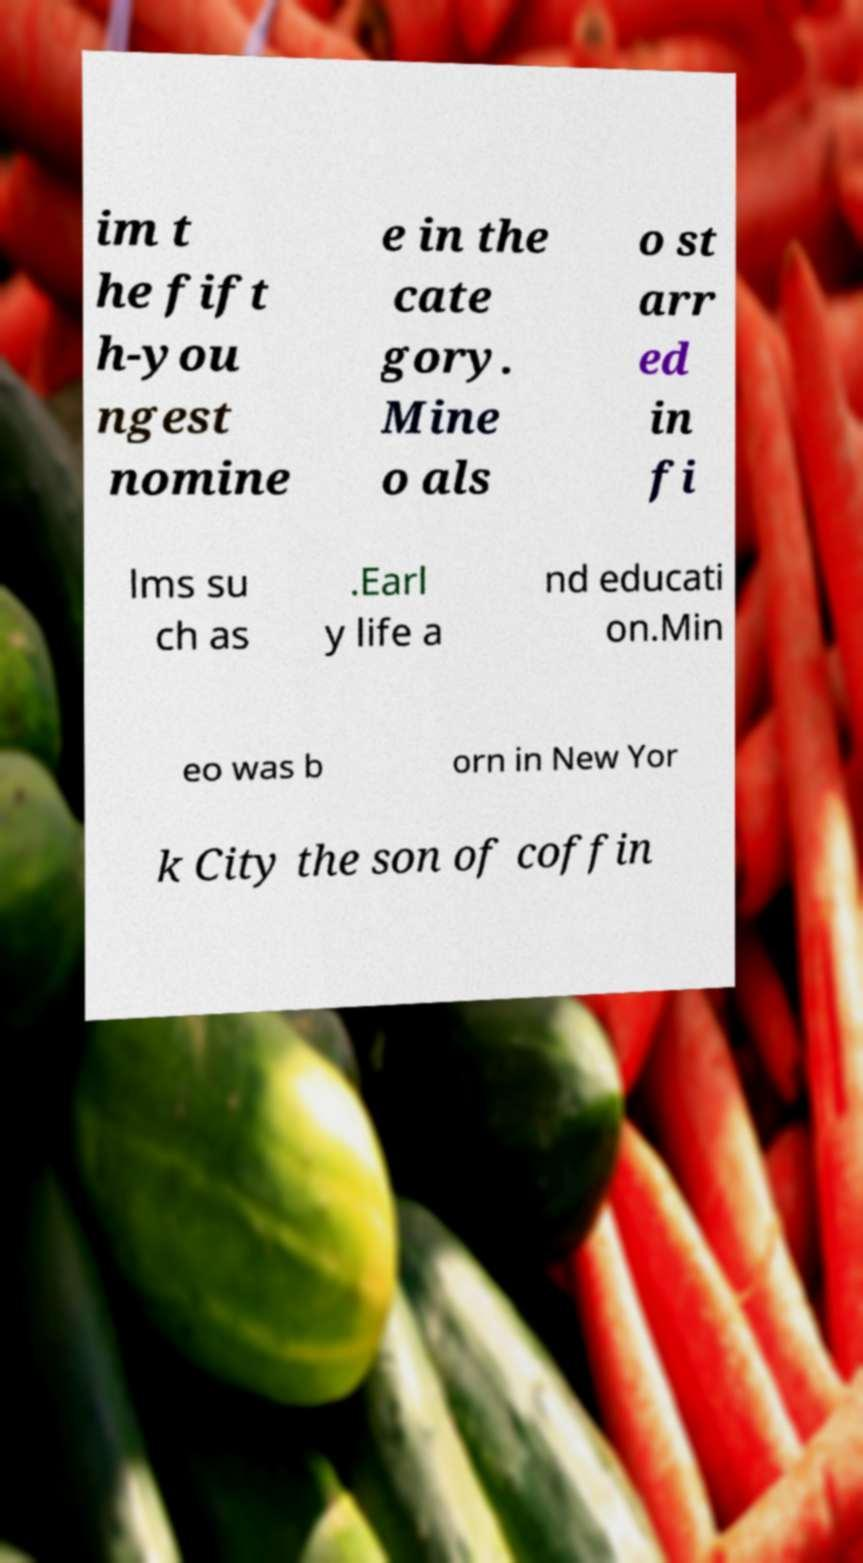There's text embedded in this image that I need extracted. Can you transcribe it verbatim? im t he fift h-you ngest nomine e in the cate gory. Mine o als o st arr ed in fi lms su ch as .Earl y life a nd educati on.Min eo was b orn in New Yor k City the son of coffin 